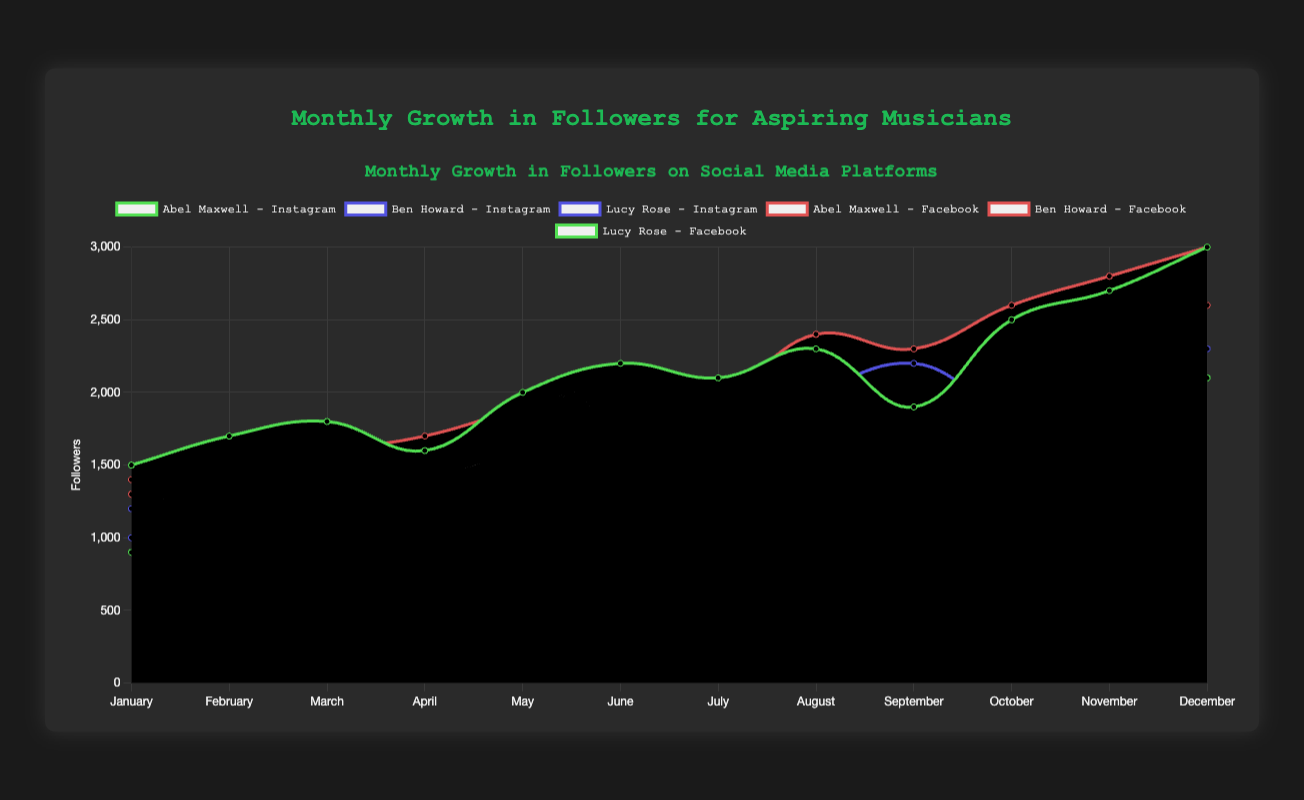Which musician had the greatest increase in followers on Instagram from January to December? To determine the musician with the greatest increase on Instagram, we look at the followers in January and December for each musician. Abel Maxwell increased from 1500 to 3000 (1500 increase), Ben Howard from 1200 to 2300 (1100 increase), and Lucy Rose from 1000 to 2300 (1300 increase). Abel Maxwell had the greatest increase.
Answer: Abel Maxwell How did Abel Maxwell's follower growth on Instagram and Facebook compare in June? For June, Abel Maxwell had 2200 followers on Instagram and 2100 followers on Facebook. Comparing these figures, the growth on Instagram is slightly higher than on Facebook.
Answer: Slightly higher on Instagram Who had the highest number of followers on Facebook in October? Observing the data for October, Abel Maxwell had 2600 followers, Ben Howard had 2200 followers, and Lucy Rose had 2000 followers on Facebook. Hence, Abel Maxwell had the highest number.
Answer: Abel Maxwell Between which months did Abel Maxwell see the largest monthly gain in followers on Instagram? To find this, I look at the month-to-month changes for Abel Maxwell on Instagram: January-February (200), February-March (100), March-April (-200), April-May (400), May-June (200), June-July (-100), July-August (200), August-September (-400), September-October (600), October-November (200), November-December (300). The largest gain was between September and October, a gain of 600 followers.
Answer: September to October What was the average number of followers for Lucy Rose on Facebook across the year? Summing Lucy Rose’s followers on Facebook from January to December: 900 + 1000 + 1100 + 1200 + 1400 + 1300 + 1500 + 1700 + 1800 + 2000 + 1900 + 2100 = 18900. Dividing by 12 months, the average is 18900 / 12 = 1575.
Answer: 1575 In which two consecutive months did Ben Howard experience a decline in followers on Facebook? Checking the values for Ben Howard on Facebook: January (1300), February (1400), March (1500), April (1300), and the June (1700), July (1600), the declines are April (1300) and July (1600) respectively. The consecutive months are April (a decline from March by 200) and July (a decline from June by 100).
Answer: April, July How does the trend in monthly growth differ for Abel Maxwell between Instagram and Facebook? Analyzing the trends, both platforms show an overall increase from January to December, but Instagram has more fluctuations with several months of decline (e.g., March-April, July-August, September-October). Facebook shows a more steady growth with fewer declines. Thus, Instagram is more fluctuating, whereas Facebook is steadier for Abel Maxwell.
Answer: Instagram fluctuates, Facebook is steadier Which musician showed the least growth in followers on Instagram from March to April? From March to April: Abel Maxwell decreased from 1800 to 1600 (a decline of 200), Ben Howard increased from 1300 to 1500 (increase of 200), and Lucy Rose increased from 1200 to 1400 (increase of 200). Hence, Abel Maxwell had the least growth (negative growth).
Answer: Abel Maxwell Comparing January and December, who had the smallest increase in followers on Facebook? Between January and December on Facebook, Abel Maxwell increased from 1400 to 3000 (1600 increase), Ben Howard increased from 1300 to 2600 (1300 increase), and Lucy Rose increased from 900 to 2100 (1200 increase). Therefore, Lucy Rose had the smallest increase.
Answer: Lucy Rose 